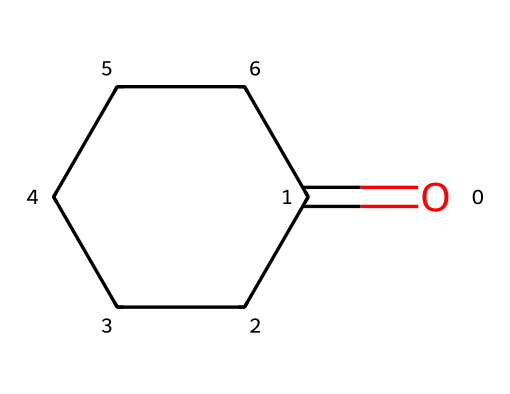What is the molecular formula of cyclohexanone? To determine the molecular formula, you can count the number of carbon (C), hydrogen (H), and oxygen (O) atoms in the cyclohexanone structure. It contains 6 carbon atoms, 10 hydrogen atoms, and 1 oxygen atom, leading to the formula C6H10O.
Answer: C6H10O How many rings are present in cyclohexanone? The structure of cyclohexanone clearly shows one cyclic component, which is a six-membered ring formed by the carbon atoms.
Answer: 1 What type of functional group is present in cyclohexanone? Looking at the structure, the carbonyl group (=O) bonded to one of the carbons in the ring indicates that cyclohexanone is a ketone.
Answer: ketone What is the total number of hydrogen atoms in cyclohexanone? By examining the structure, cyclohexanone has 10 hydrogen atoms connected to its carbon backbone while taking into account the saturation of the ring and the presence of the carbonyl group.
Answer: 10 How does the presence of the carbonyl group influence the reactivity of cyclohexanone? The presence of the carbonyl group (C=O) in cyclohexanone significantly increases its reactivity, making it susceptible to nucleophilic attacks and allowing it to participate in various chemical reactions such as oxidation and reduction.
Answer: increases reactivity What is the role of cyclohexanone in drug synthesis? Cyclohexanone serves as a key intermediate in the synthesis of various pharmaceuticals, often used as a solvent or reactant in the formation of more complex molecules due to its reactivity as a ketone.
Answer: key intermediate Which atom in cyclohexanone serves as the site of the carbonyl group? The carbonyl group is indicated by the oxygen atom that is double-bonded to one of the carbon atoms in the six-membered ring of cyclohexanone.
Answer: oxygen atom 